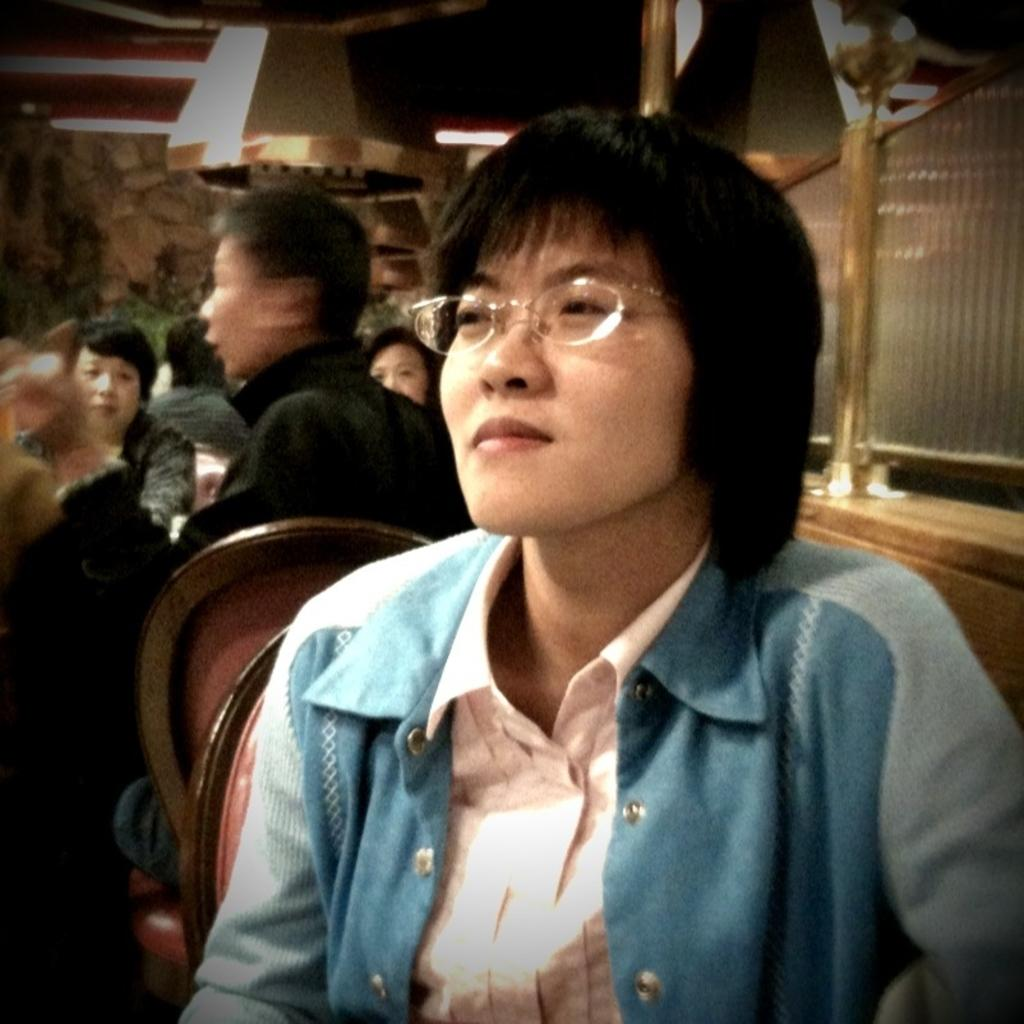Who is the main subject in the foreground of the image? There is a woman in the foreground of the image. Can you describe the people behind the woman? There are other people behind the woman. What objects can be seen on the right side of the image? There are two glasses on the right side of the image. What type of seed can be seen growing on the branch in the image? There is no branch or seed present in the image. How many cakes are visible on the table in the image? There is no table or cakes present in the image. 